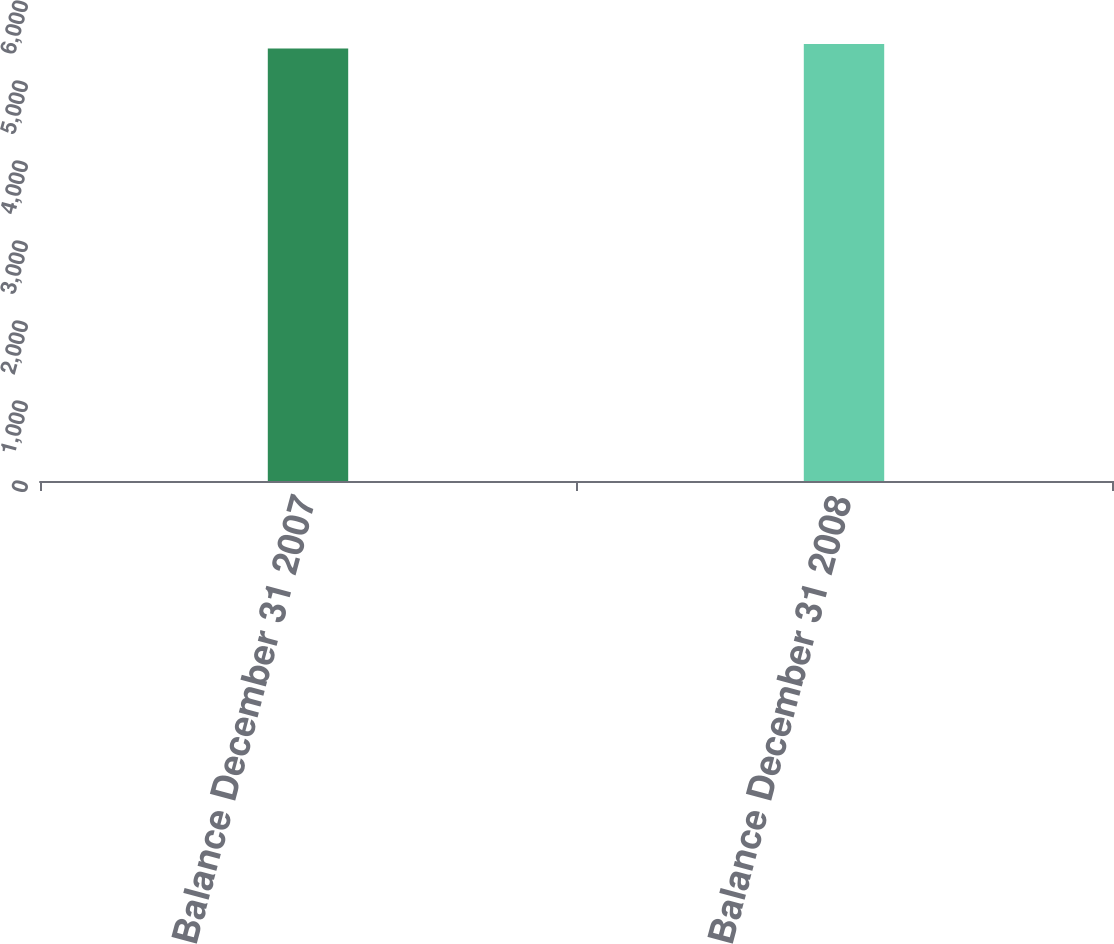<chart> <loc_0><loc_0><loc_500><loc_500><bar_chart><fcel>Balance December 31 2007<fcel>Balance December 31 2008<nl><fcel>5406<fcel>5462<nl></chart> 